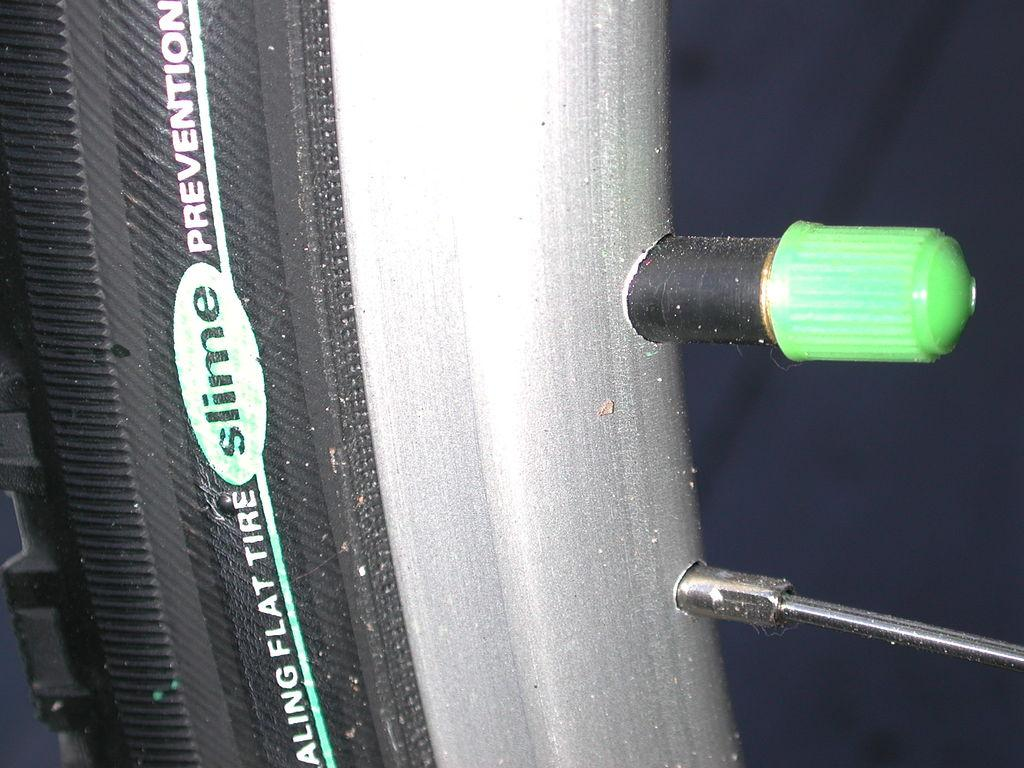<image>
Write a terse but informative summary of the picture. Flat tire slime prevention type of tire for a bike 